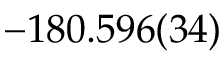<formula> <loc_0><loc_0><loc_500><loc_500>- 1 8 0 . 5 9 6 ( 3 4 )</formula> 